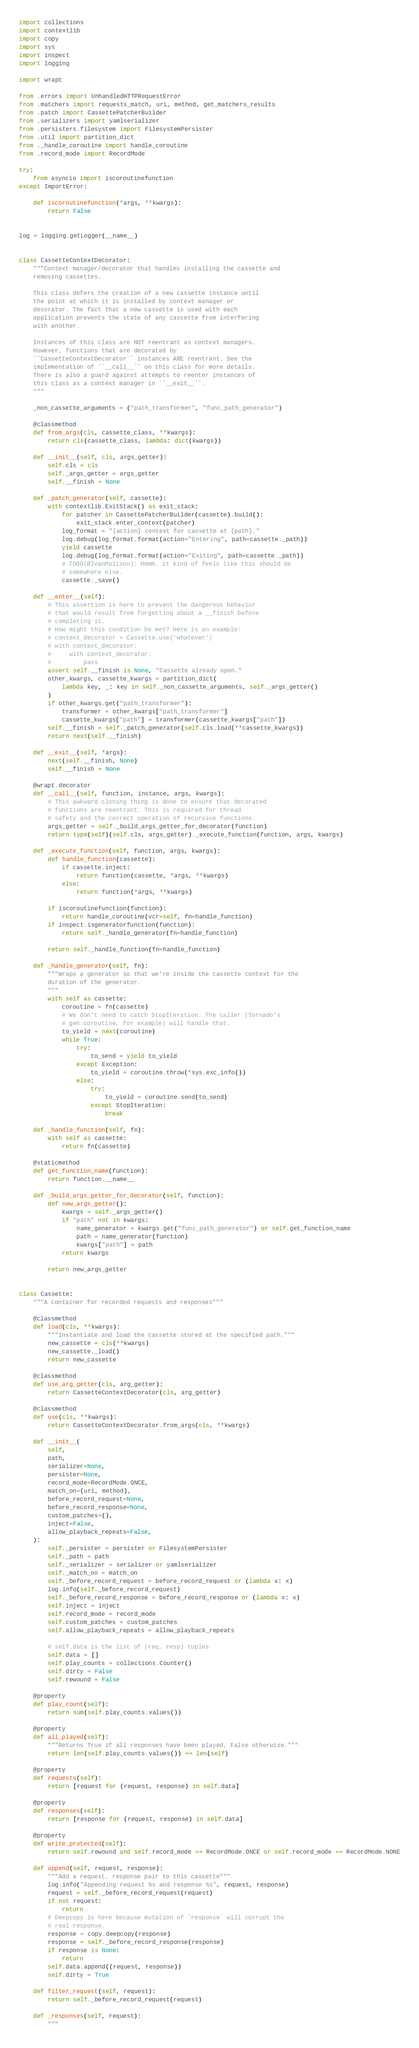<code> <loc_0><loc_0><loc_500><loc_500><_Python_>import collections
import contextlib
import copy
import sys
import inspect
import logging

import wrapt

from .errors import UnhandledHTTPRequestError
from .matchers import requests_match, uri, method, get_matchers_results
from .patch import CassettePatcherBuilder
from .serializers import yamlserializer
from .persisters.filesystem import FilesystemPersister
from .util import partition_dict
from ._handle_coroutine import handle_coroutine
from .record_mode import RecordMode

try:
    from asyncio import iscoroutinefunction
except ImportError:

    def iscoroutinefunction(*args, **kwargs):
        return False


log = logging.getLogger(__name__)


class CassetteContextDecorator:
    """Context manager/decorator that handles installing the cassette and
    removing cassettes.

    This class defers the creation of a new cassette instance until
    the point at which it is installed by context manager or
    decorator. The fact that a new cassette is used with each
    application prevents the state of any cassette from interfering
    with another.

    Instances of this class are NOT reentrant as context managers.
    However, functions that are decorated by
    ``CassetteContextDecorator`` instances ARE reentrant. See the
    implementation of ``__call__`` on this class for more details.
    There is also a guard against attempts to reenter instances of
    this class as a context manager in ``__exit__``.
    """

    _non_cassette_arguments = ("path_transformer", "func_path_generator")

    @classmethod
    def from_args(cls, cassette_class, **kwargs):
        return cls(cassette_class, lambda: dict(kwargs))

    def __init__(self, cls, args_getter):
        self.cls = cls
        self._args_getter = args_getter
        self.__finish = None

    def _patch_generator(self, cassette):
        with contextlib.ExitStack() as exit_stack:
            for patcher in CassettePatcherBuilder(cassette).build():
                exit_stack.enter_context(patcher)
            log_format = "{action} context for cassette at {path}."
            log.debug(log_format.format(action="Entering", path=cassette._path))
            yield cassette
            log.debug(log_format.format(action="Exiting", path=cassette._path))
            # TODO(@IvanMalison): Hmmm. it kind of feels like this should be
            # somewhere else.
            cassette._save()

    def __enter__(self):
        # This assertion is here to prevent the dangerous behavior
        # that would result from forgetting about a __finish before
        # completing it.
        # How might this condition be met? Here is an example:
        # context_decorator = Cassette.use('whatever')
        # with context_decorator:
        #     with context_decorator:
        #         pass
        assert self.__finish is None, "Cassette already open."
        other_kwargs, cassette_kwargs = partition_dict(
            lambda key, _: key in self._non_cassette_arguments, self._args_getter()
        )
        if other_kwargs.get("path_transformer"):
            transformer = other_kwargs["path_transformer"]
            cassette_kwargs["path"] = transformer(cassette_kwargs["path"])
        self.__finish = self._patch_generator(self.cls.load(**cassette_kwargs))
        return next(self.__finish)

    def __exit__(self, *args):
        next(self.__finish, None)
        self.__finish = None

    @wrapt.decorator
    def __call__(self, function, instance, args, kwargs):
        # This awkward cloning thing is done to ensure that decorated
        # functions are reentrant. This is required for thread
        # safety and the correct operation of recursive functions.
        args_getter = self._build_args_getter_for_decorator(function)
        return type(self)(self.cls, args_getter)._execute_function(function, args, kwargs)

    def _execute_function(self, function, args, kwargs):
        def handle_function(cassette):
            if cassette.inject:
                return function(cassette, *args, **kwargs)
            else:
                return function(*args, **kwargs)

        if iscoroutinefunction(function):
            return handle_coroutine(vcr=self, fn=handle_function)
        if inspect.isgeneratorfunction(function):
            return self._handle_generator(fn=handle_function)

        return self._handle_function(fn=handle_function)

    def _handle_generator(self, fn):
        """Wraps a generator so that we're inside the cassette context for the
        duration of the generator.
        """
        with self as cassette:
            coroutine = fn(cassette)
            # We don't need to catch StopIteration. The caller (Tornado's
            # gen.coroutine, for example) will handle that.
            to_yield = next(coroutine)
            while True:
                try:
                    to_send = yield to_yield
                except Exception:
                    to_yield = coroutine.throw(*sys.exc_info())
                else:
                    try:
                        to_yield = coroutine.send(to_send)
                    except StopIteration:
                        break

    def _handle_function(self, fn):
        with self as cassette:
            return fn(cassette)

    @staticmethod
    def get_function_name(function):
        return function.__name__

    def _build_args_getter_for_decorator(self, function):
        def new_args_getter():
            kwargs = self._args_getter()
            if "path" not in kwargs:
                name_generator = kwargs.get("func_path_generator") or self.get_function_name
                path = name_generator(function)
                kwargs["path"] = path
            return kwargs

        return new_args_getter


class Cassette:
    """A container for recorded requests and responses"""

    @classmethod
    def load(cls, **kwargs):
        """Instantiate and load the cassette stored at the specified path."""
        new_cassette = cls(**kwargs)
        new_cassette._load()
        return new_cassette

    @classmethod
    def use_arg_getter(cls, arg_getter):
        return CassetteContextDecorator(cls, arg_getter)

    @classmethod
    def use(cls, **kwargs):
        return CassetteContextDecorator.from_args(cls, **kwargs)

    def __init__(
        self,
        path,
        serializer=None,
        persister=None,
        record_mode=RecordMode.ONCE,
        match_on=(uri, method),
        before_record_request=None,
        before_record_response=None,
        custom_patches=(),
        inject=False,
        allow_playback_repeats=False,
    ):
        self._persister = persister or FilesystemPersister
        self._path = path
        self._serializer = serializer or yamlserializer
        self._match_on = match_on
        self._before_record_request = before_record_request or (lambda x: x)
        log.info(self._before_record_request)
        self._before_record_response = before_record_response or (lambda x: x)
        self.inject = inject
        self.record_mode = record_mode
        self.custom_patches = custom_patches
        self.allow_playback_repeats = allow_playback_repeats

        # self.data is the list of (req, resp) tuples
        self.data = []
        self.play_counts = collections.Counter()
        self.dirty = False
        self.rewound = False

    @property
    def play_count(self):
        return sum(self.play_counts.values())

    @property
    def all_played(self):
        """Returns True if all responses have been played, False otherwise."""
        return len(self.play_counts.values()) == len(self)

    @property
    def requests(self):
        return [request for (request, response) in self.data]

    @property
    def responses(self):
        return [response for (request, response) in self.data]

    @property
    def write_protected(self):
        return self.rewound and self.record_mode == RecordMode.ONCE or self.record_mode == RecordMode.NONE

    def append(self, request, response):
        """Add a request, response pair to this cassette"""
        log.info("Appending request %s and response %s", request, response)
        request = self._before_record_request(request)
        if not request:
            return
        # Deepcopy is here because mutation of `response` will corrupt the
        # real response.
        response = copy.deepcopy(response)
        response = self._before_record_response(response)
        if response is None:
            return
        self.data.append((request, response))
        self.dirty = True

    def filter_request(self, request):
        return self._before_record_request(request)

    def _responses(self, request):
        """</code> 